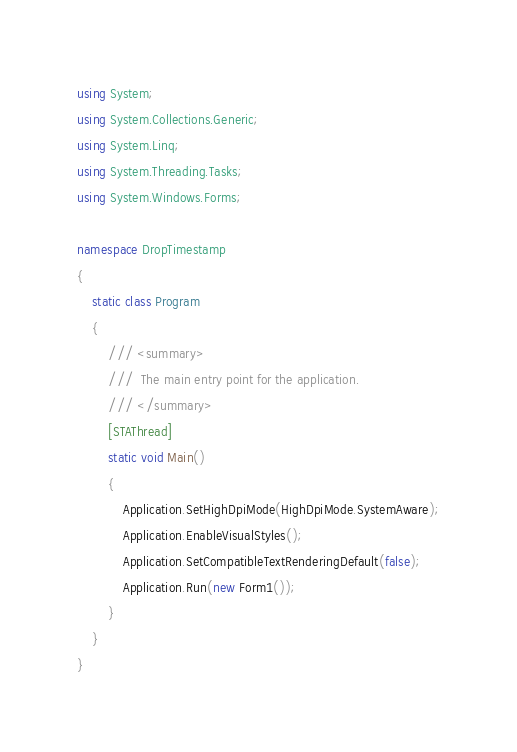Convert code to text. <code><loc_0><loc_0><loc_500><loc_500><_C#_>using System;
using System.Collections.Generic;
using System.Linq;
using System.Threading.Tasks;
using System.Windows.Forms;

namespace DropTimestamp
{
    static class Program
    {
        /// <summary>
        ///  The main entry point for the application.
        /// </summary>
        [STAThread]
        static void Main()
        {
            Application.SetHighDpiMode(HighDpiMode.SystemAware);
            Application.EnableVisualStyles();
            Application.SetCompatibleTextRenderingDefault(false);
            Application.Run(new Form1());
        }
    }
}</code> 